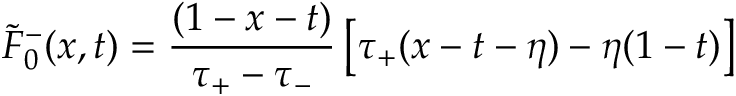Convert formula to latex. <formula><loc_0><loc_0><loc_500><loc_500>\widetilde { F } _ { 0 } ^ { - } ( x , t ) = { \frac { ( 1 - x - t ) } { \tau _ { + } - \tau _ { - } } } \left [ \tau _ { + } ( x - t - \eta ) - \eta ( 1 - t ) \right ]</formula> 